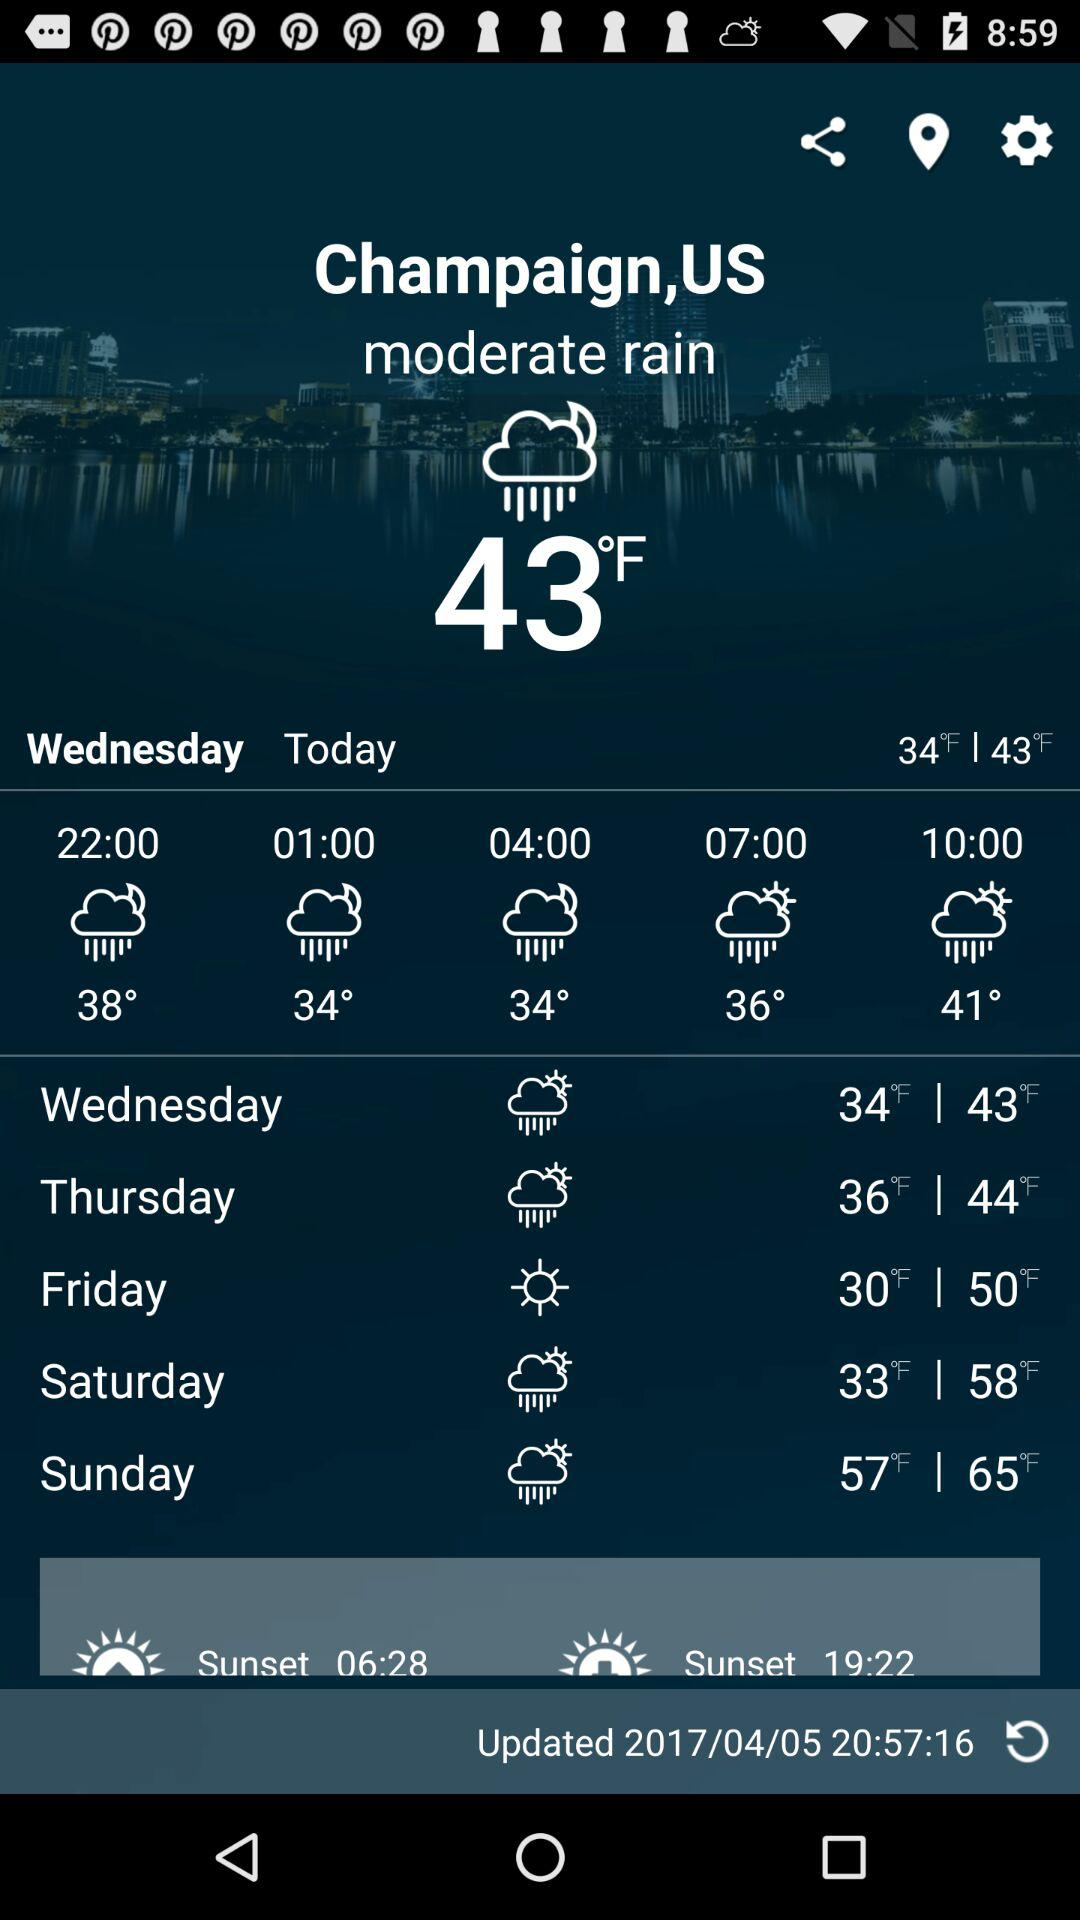Will it rain tomorrow?
When the provided information is insufficient, respond with <no answer>. <no answer> 